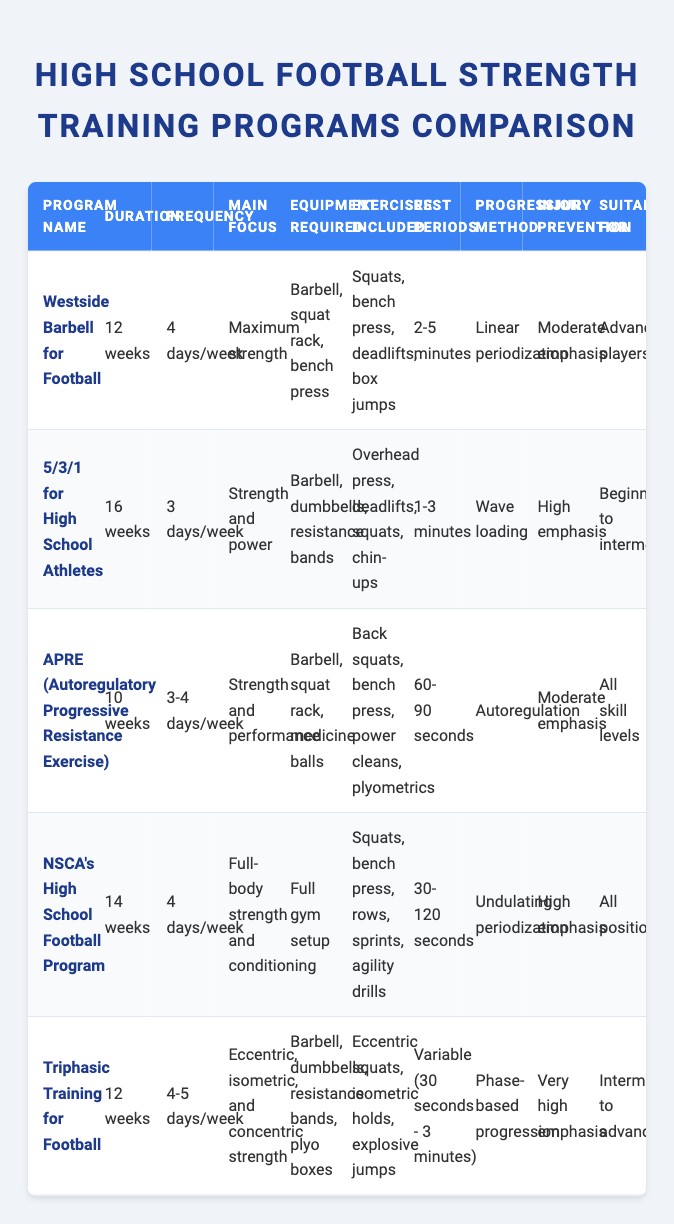What is the main focus of the "NSCA's High School Football Program"? From the table, I can directly look at the "Main Focus" column for the row corresponding to "NSCA's High School Football Program". The main focus listed there is "Full-body strength and conditioning".
Answer: Full-body strength and conditioning How many weeks does the "5/3/1 for High School Athletes" program last? Looking at the "Duration" column for the "5/3/1 for High School Athletes", it states that the program lasts for "16 weeks".
Answer: 16 weeks Which program has the highest emphasis on injury prevention? I need to examine the "Injury Prevention" column across all programs. The "Triphasic Training for Football" program states "Very high emphasis", which is higher than all others.
Answer: Triphasic Training for Football What is the average duration of the strength training programs listed? First, I need to convert the durations into numerical values: 12, 16, 10, 14, and 12 weeks. Summing these (12 + 16 + 10 + 14 + 12) equals 64 weeks. There are 5 programs, so I divide 64 by 5, yielding an average of 12.8 weeks.
Answer: 12.8 weeks Is the "APRE (Autoregulatory Progressive Resistance Exercise)" program suitable for advanced players? By checking the "Suitable For" column for "APRE (Autoregulatory Progressive Resistance Exercise)", it shows "All skill levels", which indicates it is not specifically for advanced players.
Answer: No What types of equipment are required for "Westside Barbell for Football" and "APRE (Autoregulatory Progressive Resistance Exercise)"? For "Westside Barbell for Football", the required equipment is "Barbell, squat rack, bench press" while for "APRE", it requires "Barbell, squat rack, medicine balls". Now I can compare these two responses.
Answer: Barbell, squat rack, bench press; Barbell, squat rack, medicine balls Which program has the longest duration and the least frequency? Reviewing the durations, "5/3/1 for High School Athletes" has the longest at 16 weeks, while frequency is "3 days/week". This program fits the criteria of the longest duration with the least frequency.
Answer: 5/3/1 for High School Athletes Does the "Triphasic Training for Football" offer a phase-based progression method? The "Progression Method" for "Triphasic Training for Football" is specifically noted as "Phase-based progression", confirming that it does offer this method.
Answer: Yes What is the range of rest periods for the "Triphasic Training for Football"? From the "Rest Periods" column, it states "Variable (30 seconds - 3 minutes)" for "Triphasic Training for Football," indicating this range is the answer.
Answer: 30 seconds - 3 minutes 